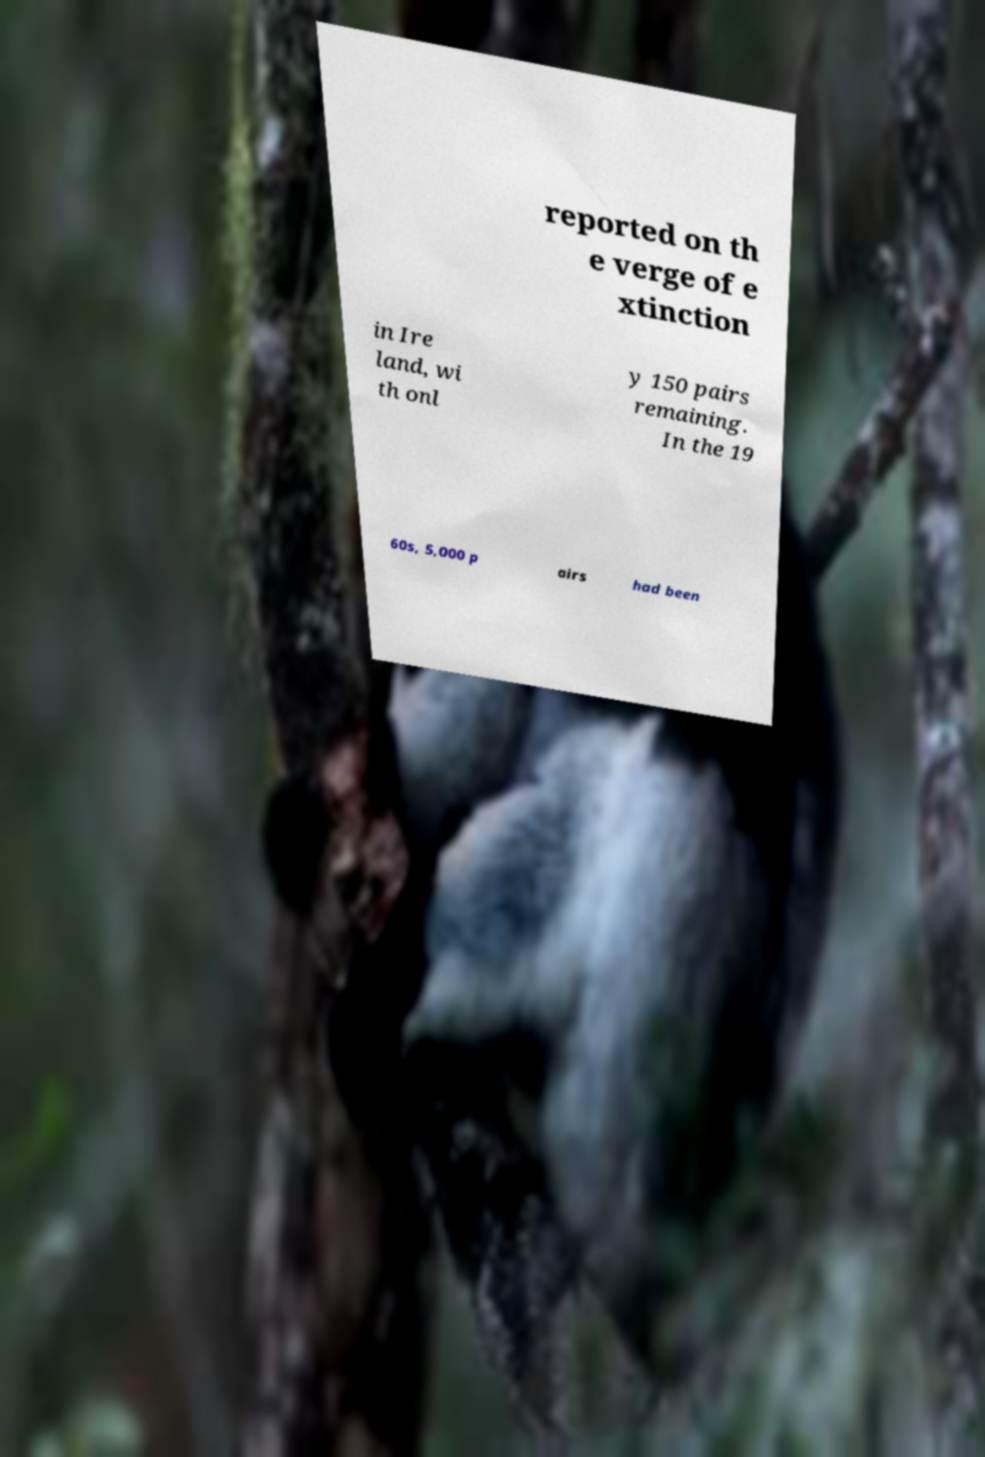Could you assist in decoding the text presented in this image and type it out clearly? reported on th e verge of e xtinction in Ire land, wi th onl y 150 pairs remaining. In the 19 60s, 5,000 p airs had been 